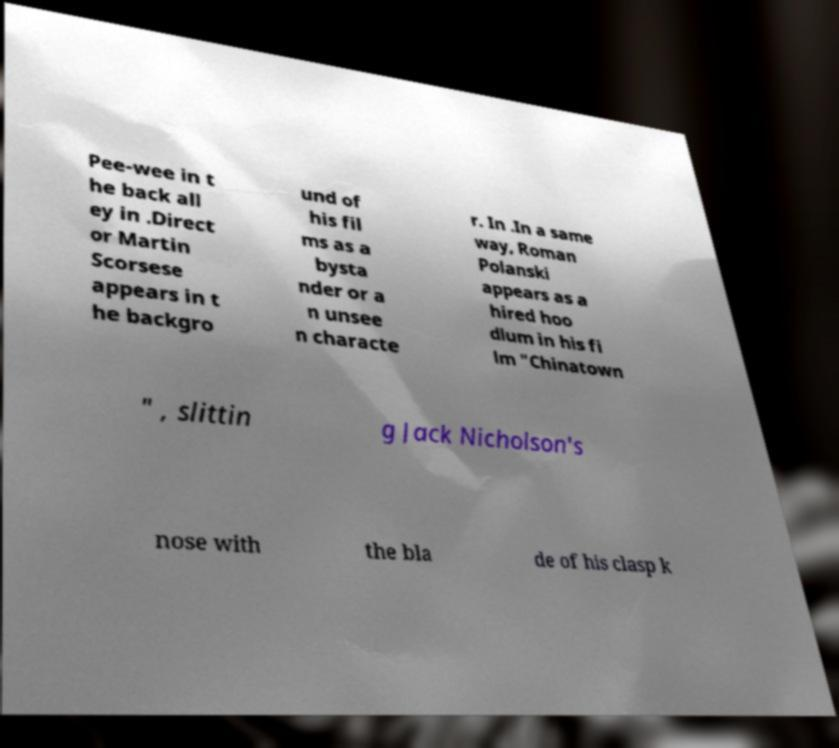Could you extract and type out the text from this image? Pee-wee in t he back all ey in .Direct or Martin Scorsese appears in t he backgro und of his fil ms as a bysta nder or a n unsee n characte r. In .In a same way, Roman Polanski appears as a hired hoo dlum in his fi lm "Chinatown " , slittin g Jack Nicholson's nose with the bla de of his clasp k 